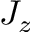<formula> <loc_0><loc_0><loc_500><loc_500>J _ { z }</formula> 